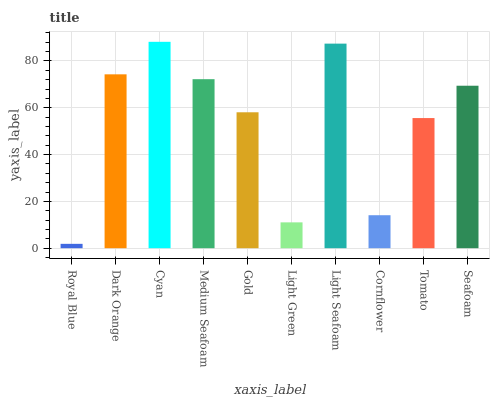Is Royal Blue the minimum?
Answer yes or no. Yes. Is Cyan the maximum?
Answer yes or no. Yes. Is Dark Orange the minimum?
Answer yes or no. No. Is Dark Orange the maximum?
Answer yes or no. No. Is Dark Orange greater than Royal Blue?
Answer yes or no. Yes. Is Royal Blue less than Dark Orange?
Answer yes or no. Yes. Is Royal Blue greater than Dark Orange?
Answer yes or no. No. Is Dark Orange less than Royal Blue?
Answer yes or no. No. Is Seafoam the high median?
Answer yes or no. Yes. Is Gold the low median?
Answer yes or no. Yes. Is Gold the high median?
Answer yes or no. No. Is Light Green the low median?
Answer yes or no. No. 